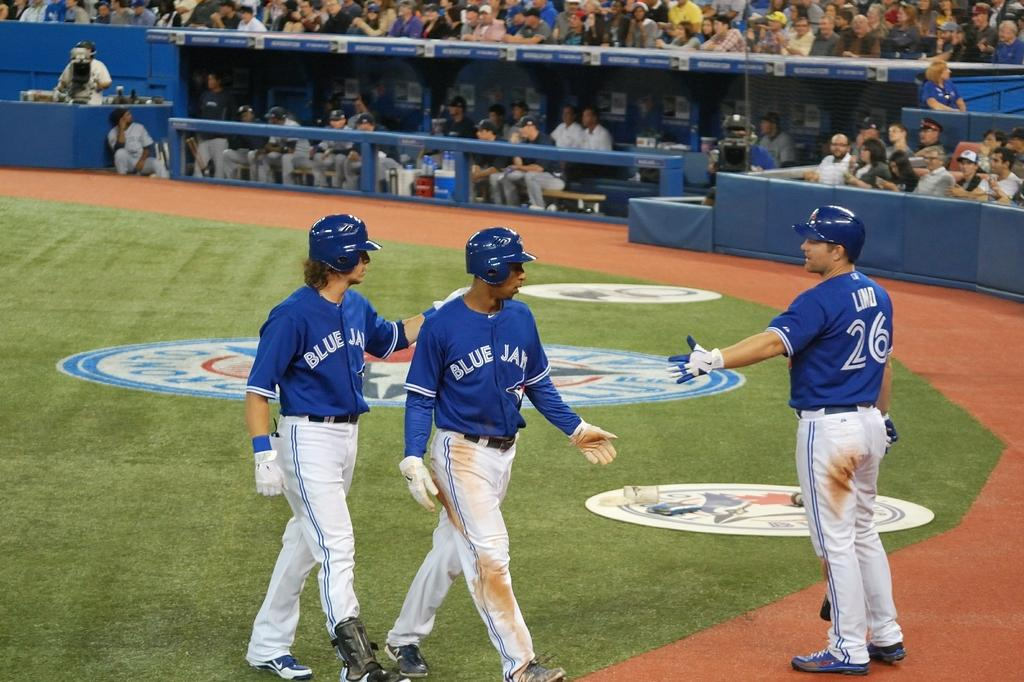<image>
Write a terse but informative summary of the picture. Two players from the Blue Jays are being offered a hand slap by someone else on their team. 